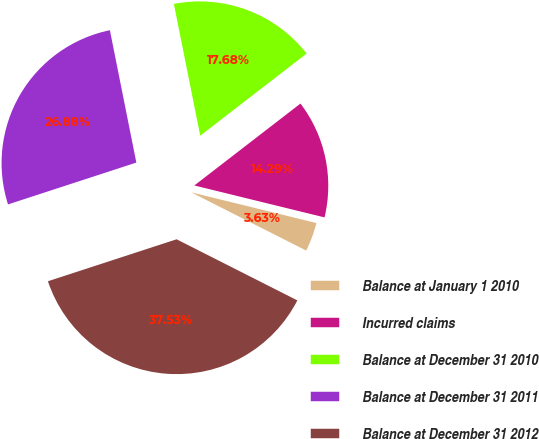Convert chart to OTSL. <chart><loc_0><loc_0><loc_500><loc_500><pie_chart><fcel>Balance at January 1 2010<fcel>Incurred claims<fcel>Balance at December 31 2010<fcel>Balance at December 31 2011<fcel>Balance at December 31 2012<nl><fcel>3.63%<fcel>14.29%<fcel>17.68%<fcel>26.88%<fcel>37.53%<nl></chart> 